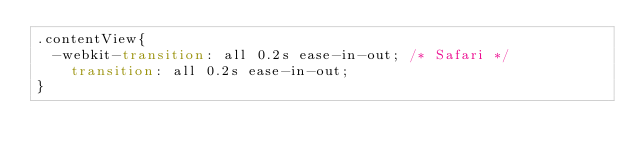<code> <loc_0><loc_0><loc_500><loc_500><_CSS_>.contentView{
	-webkit-transition: all 0.2s ease-in-out; /* Safari */
    transition: all 0.2s ease-in-out;
}</code> 